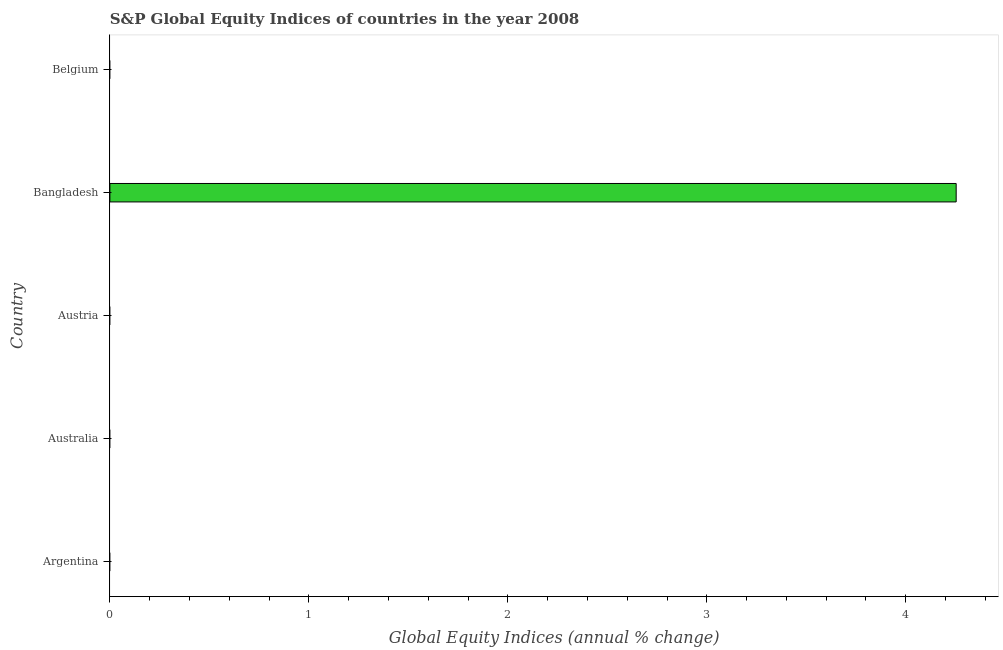What is the title of the graph?
Offer a terse response. S&P Global Equity Indices of countries in the year 2008. What is the label or title of the X-axis?
Make the answer very short. Global Equity Indices (annual % change). What is the label or title of the Y-axis?
Provide a short and direct response. Country. What is the s&p global equity indices in Argentina?
Your answer should be very brief. 0. Across all countries, what is the maximum s&p global equity indices?
Offer a very short reply. 4.25. Across all countries, what is the minimum s&p global equity indices?
Offer a very short reply. 0. In which country was the s&p global equity indices maximum?
Your response must be concise. Bangladesh. What is the sum of the s&p global equity indices?
Offer a very short reply. 4.25. What is the average s&p global equity indices per country?
Your answer should be very brief. 0.85. What is the difference between the highest and the lowest s&p global equity indices?
Give a very brief answer. 4.25. In how many countries, is the s&p global equity indices greater than the average s&p global equity indices taken over all countries?
Your response must be concise. 1. Are all the bars in the graph horizontal?
Your response must be concise. Yes. What is the difference between two consecutive major ticks on the X-axis?
Provide a short and direct response. 1. What is the Global Equity Indices (annual % change) in Australia?
Provide a short and direct response. 0. What is the Global Equity Indices (annual % change) in Bangladesh?
Provide a succinct answer. 4.25. What is the Global Equity Indices (annual % change) of Belgium?
Offer a terse response. 0. 